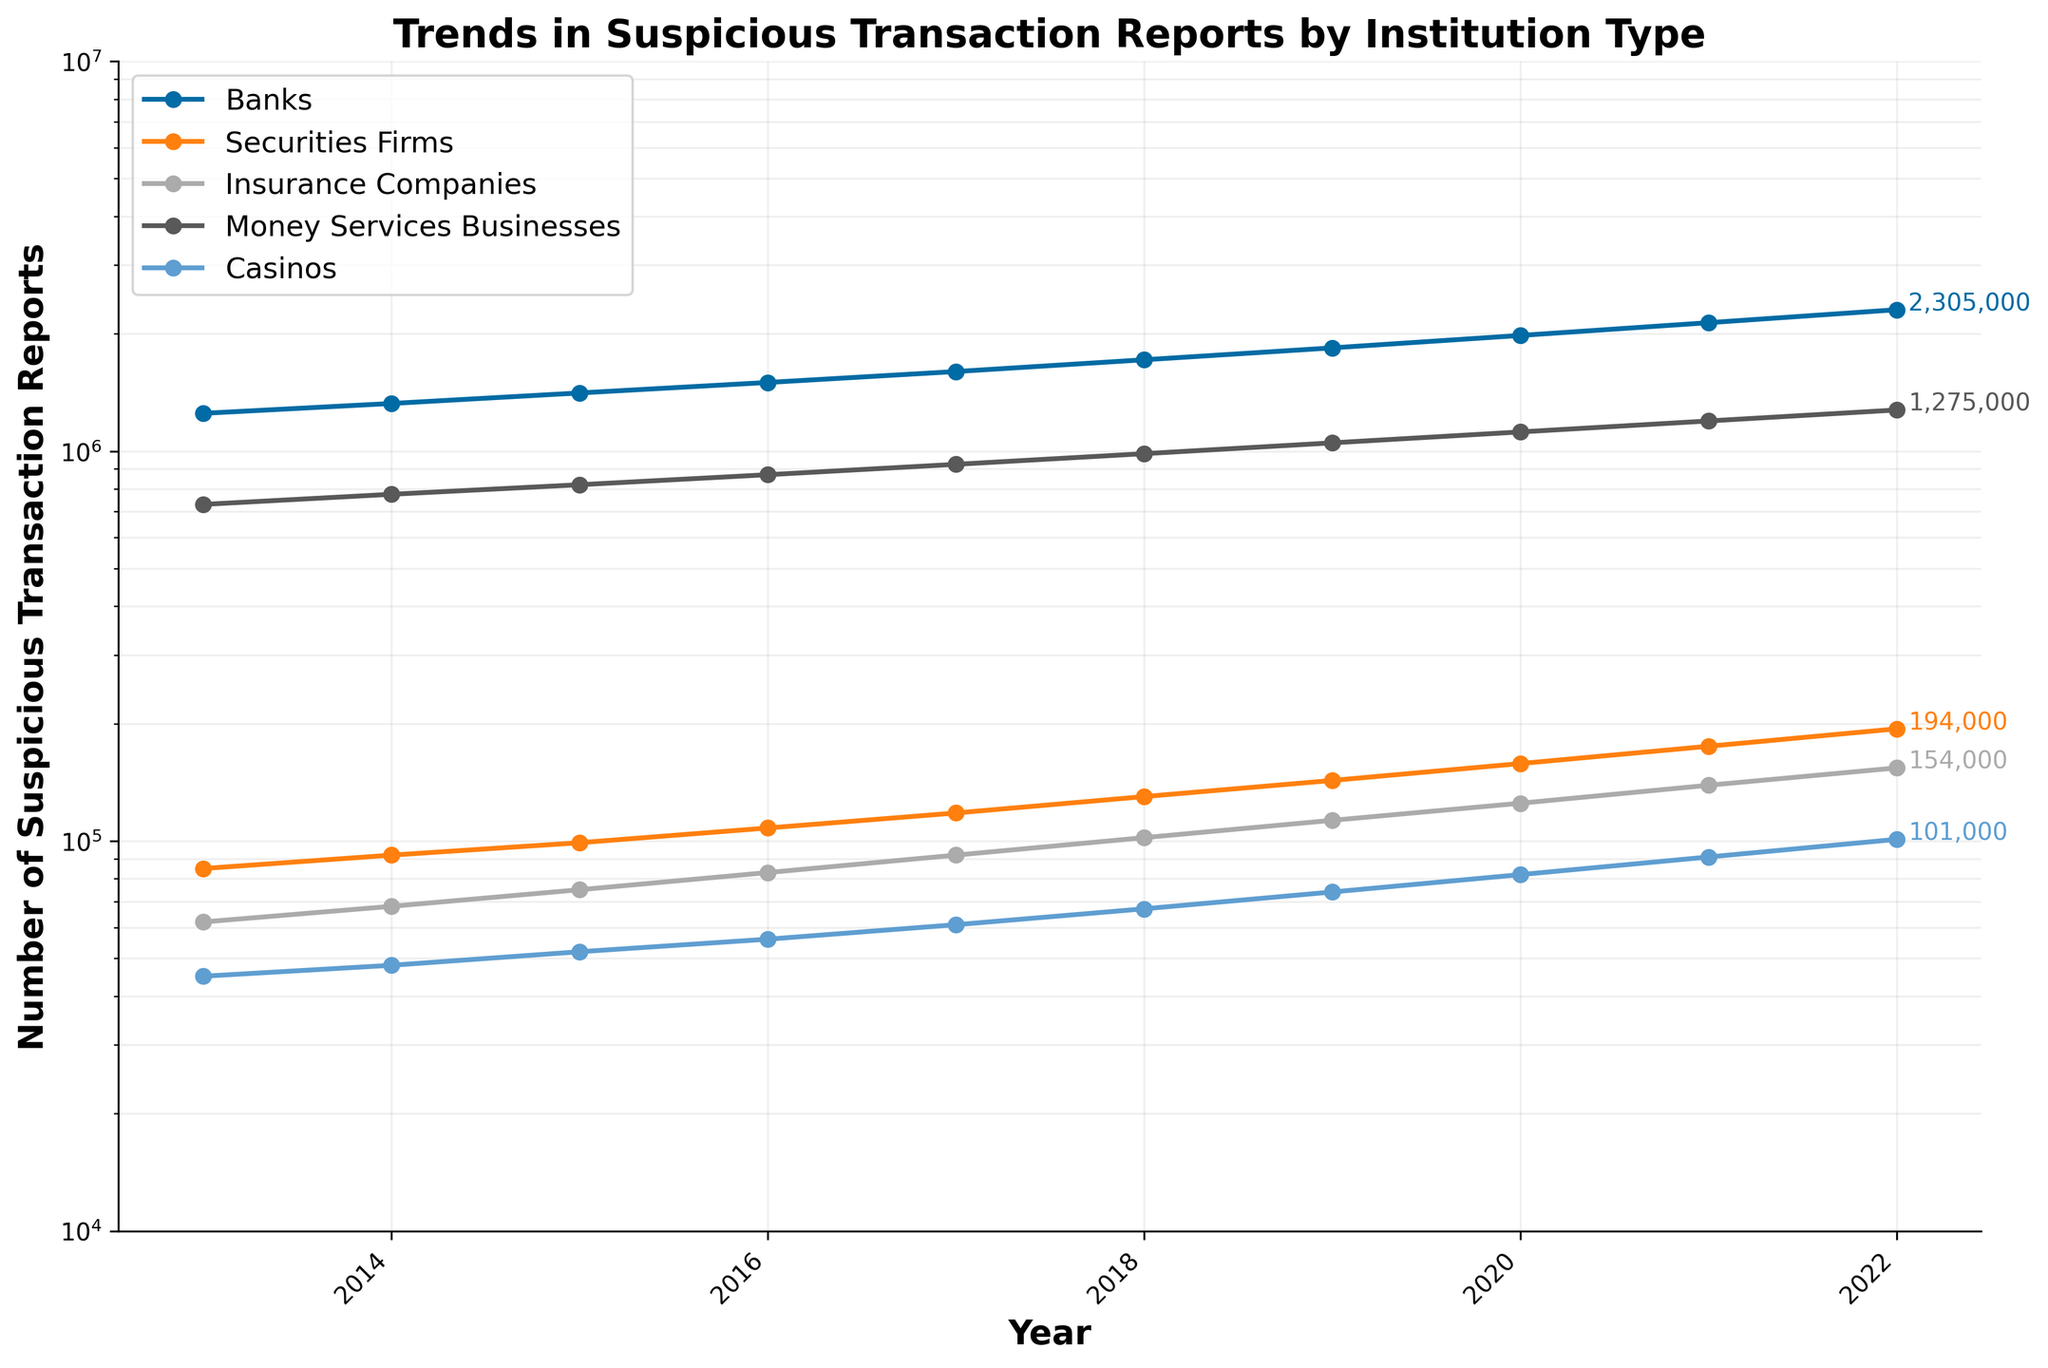What is the general trend in the number of STRs filed by banks over the decade? The quantity of suspicious transaction reports filed by banks consistently increased each year from 1,250,000 in 2013 to 2,305,000 in 2022. This indicates a general upward trend.
Answer: Upward trend Which financial institution types saw the fastest growth in the number of STRs filed from 2013 to 2022? By comparing the start and end values for each institution type, Casinos show an increase from 45,000 to 101,000, which is over a 2.24-fold increase. This is the fastest proportional growth among all types listed.
Answer: Casinos What is the difference in the number of STRs filed between Banks and Money Services Businesses in 2022? In 2022, Banks filed 2,305,000 STRs, and Money Services Businesses filed 1,275,000. The difference between these two numbers is 2,305,000 - 1,275,000 = 1,030,000.
Answer: 1,030,000 How do the STRs filed by Insurance Companies in 2022 compare to those from Securities Firms in the same year? In 2022, Insurance Companies filed 154,000 STRs, and Securities Firms filed 194,000. Comparing these two numbers, the amount from Securities Firms is higher.
Answer: Securities Firms are higher Which institution type had the smallest number of STRs filed every year? In every year from 2013 to 2022, Casinos consistently had the smallest number of STRs filed compared to other institution types.
Answer: Casinos Was there any institution type that showed a steady linear increase in STRs without fluctuations? Banks showed a continuous, steady increase in the number of STRs filed each year without any fluctuations, increasing linearly from 1,250,000 in 2013 to 2,305,000 in 2022.
Answer: Banks What is the average annual increase in the number of STRs filed by Money Services Businesses over the past decade? The number of STRs filed by Money Services Businesses rose from 730,000 in 2013 to 1,275,000 in 2022. The increase over these 10 years is 1,275,000 - 730,000 = 545,000. The average annual increase is 545,000 / 9 ≈ 60,556 per year.
Answer: Approximately 60,556 per year Between 2015 and 2020, which institution saw the highest absolute increase in the number of STRs filed? From 2015 to 2020, Banks saw an increase from 1,410,000 to 1,980,000, an increase of 570,000. Money Services Businesses went from 820,000 to 1,120,000, an increase of 300,000. Banks had the highest absolute increase.
Answer: Banks What is the ratio of the number of STRs filed by Banks to those filed by Insurance Companies in 2022? In 2022, Banks filed 2,305,000 STRs, and Insurance Companies filed 154,000. The ratio is calculated as 2,305,000 / 154,000 ≈ 14.97.
Answer: Approximately 15:1 